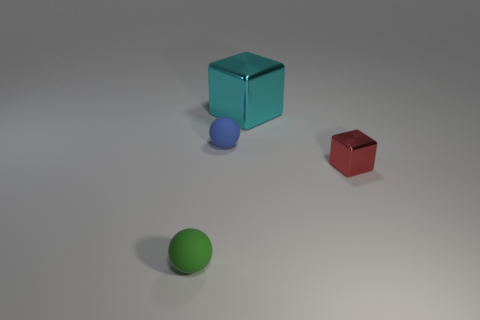Is there any other thing that is the same size as the cyan metal object?
Make the answer very short. No. Does the green thing have the same material as the ball that is behind the red shiny cube?
Your answer should be very brief. Yes. What color is the thing that is both right of the small blue object and behind the red metallic cube?
Give a very brief answer. Cyan. There is a object behind the blue rubber object; what shape is it?
Ensure brevity in your answer.  Cube. There is a metallic thing that is behind the tiny matte ball behind the cube that is right of the cyan metal thing; what size is it?
Offer a terse response. Large. What number of metal blocks are behind the shiny thing right of the big object?
Provide a short and direct response. 1. What is the size of the thing that is both left of the red shiny object and right of the blue matte sphere?
Your answer should be very brief. Large. What number of rubber objects are big brown cylinders or large blocks?
Offer a very short reply. 0. What is the cyan cube made of?
Offer a terse response. Metal. There is a block that is in front of the small thing that is behind the thing on the right side of the cyan metallic object; what is its material?
Offer a terse response. Metal. 